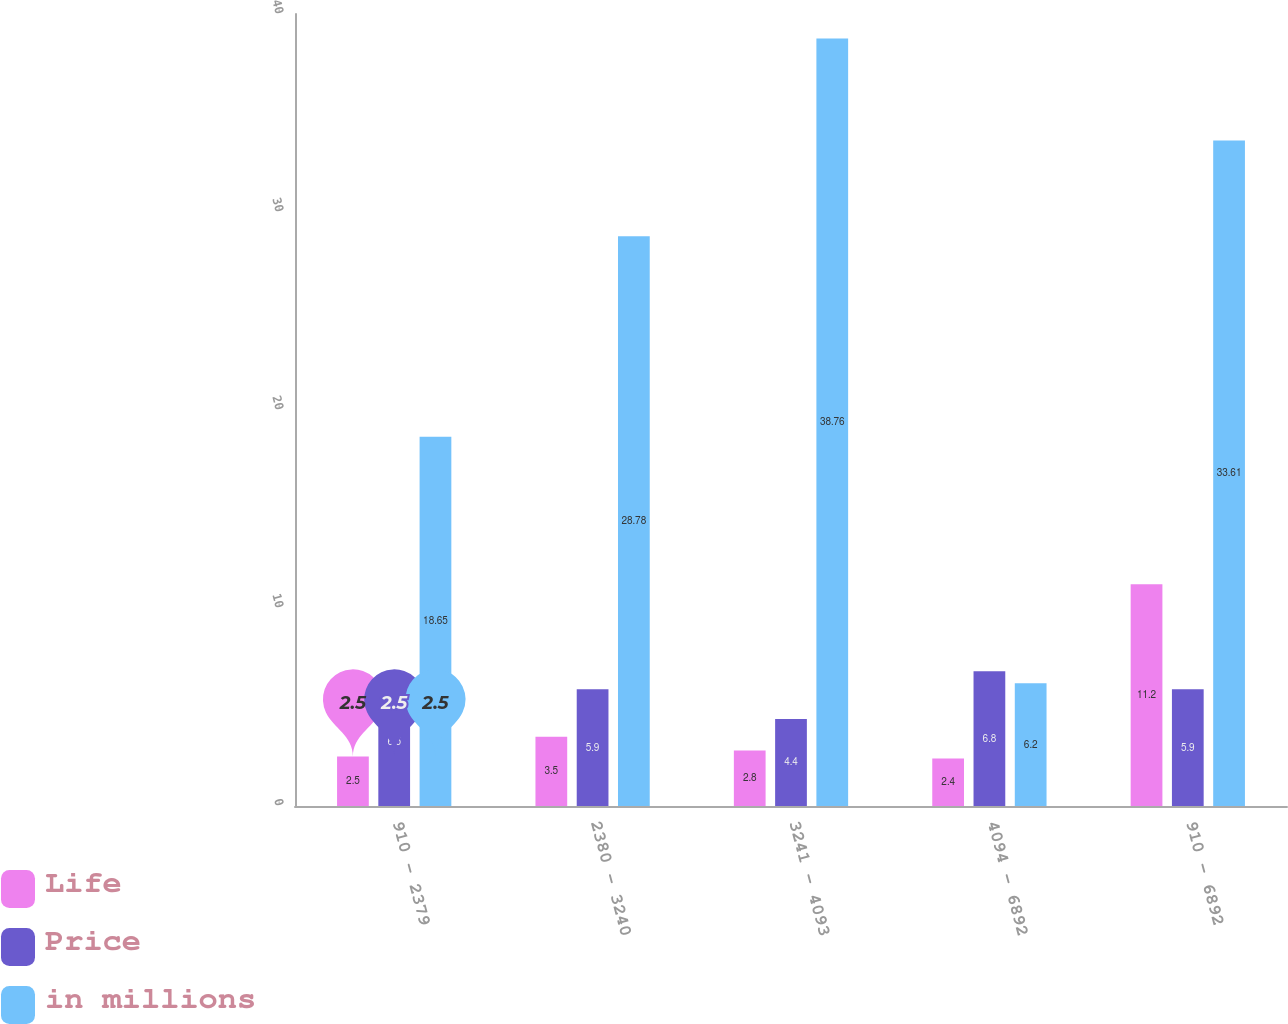Convert chart. <chart><loc_0><loc_0><loc_500><loc_500><stacked_bar_chart><ecel><fcel>910 - 2379<fcel>2380 - 3240<fcel>3241 - 4093<fcel>4094 - 6892<fcel>910 - 6892<nl><fcel>Life<fcel>2.5<fcel>3.5<fcel>2.8<fcel>2.4<fcel>11.2<nl><fcel>Price<fcel>6.5<fcel>5.9<fcel>4.4<fcel>6.8<fcel>5.9<nl><fcel>in millions<fcel>18.65<fcel>28.78<fcel>38.76<fcel>6.2<fcel>33.61<nl></chart> 